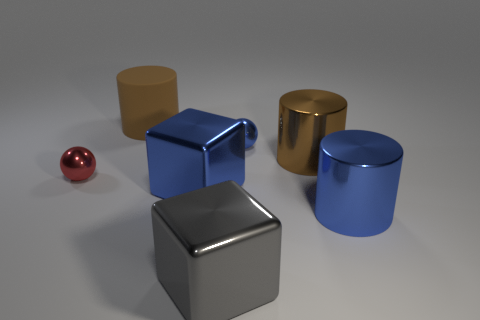There is a tiny shiny object on the right side of the small thing to the left of the rubber cylinder; what shape is it?
Keep it short and to the point. Sphere. What number of red objects are either tiny metallic things or big spheres?
Provide a succinct answer. 1. There is a big matte cylinder; are there any blue blocks behind it?
Your answer should be very brief. No. The gray block is what size?
Provide a short and direct response. Large. There is a red metal object that is the same shape as the tiny blue metallic thing; what is its size?
Offer a very short reply. Small. What number of metallic cubes are to the right of the brown cylinder behind the blue ball?
Keep it short and to the point. 2. Do the small blue object right of the brown matte cylinder and the large cylinder behind the tiny blue shiny thing have the same material?
Ensure brevity in your answer.  No. How many other objects have the same shape as the gray metallic object?
Offer a very short reply. 1. What number of large metal cylinders are the same color as the matte object?
Ensure brevity in your answer.  1. Is the shape of the large brown object right of the small blue thing the same as the object behind the blue shiny ball?
Your answer should be very brief. Yes. 